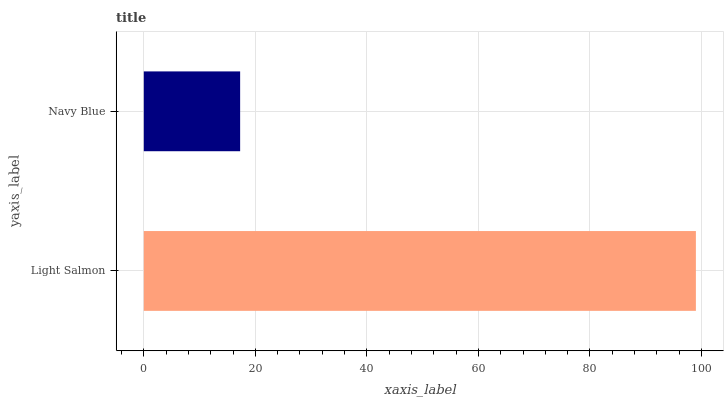Is Navy Blue the minimum?
Answer yes or no. Yes. Is Light Salmon the maximum?
Answer yes or no. Yes. Is Navy Blue the maximum?
Answer yes or no. No. Is Light Salmon greater than Navy Blue?
Answer yes or no. Yes. Is Navy Blue less than Light Salmon?
Answer yes or no. Yes. Is Navy Blue greater than Light Salmon?
Answer yes or no. No. Is Light Salmon less than Navy Blue?
Answer yes or no. No. Is Light Salmon the high median?
Answer yes or no. Yes. Is Navy Blue the low median?
Answer yes or no. Yes. Is Navy Blue the high median?
Answer yes or no. No. Is Light Salmon the low median?
Answer yes or no. No. 